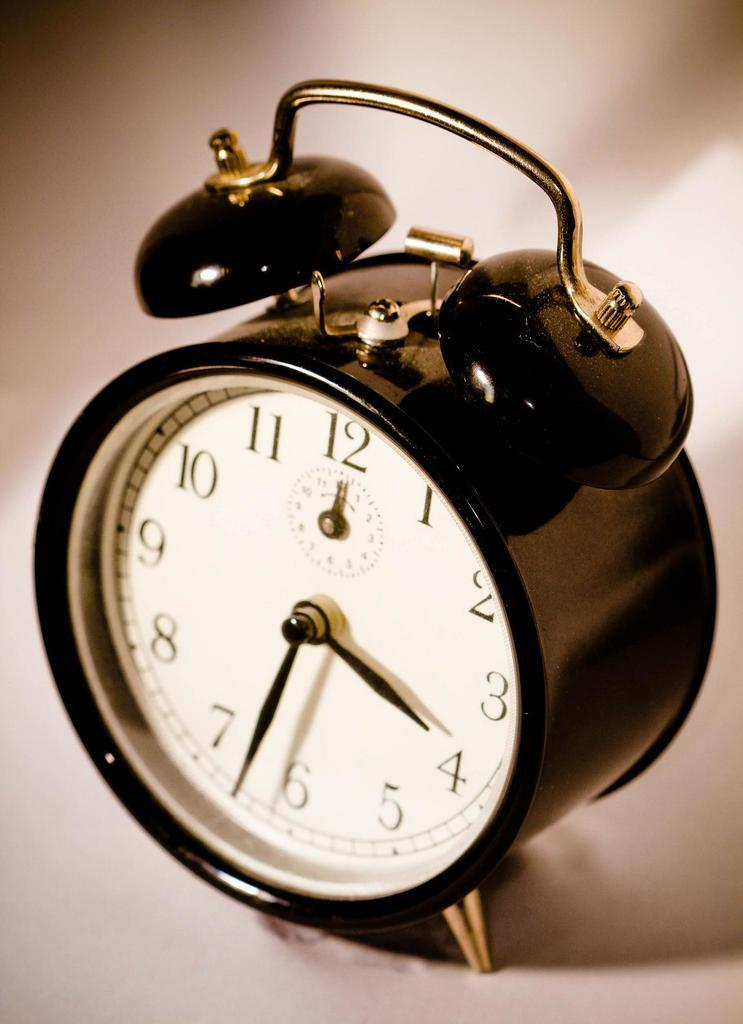<image>
Relay a brief, clear account of the picture shown. a small black alarm clock that says '4:33' o nit 